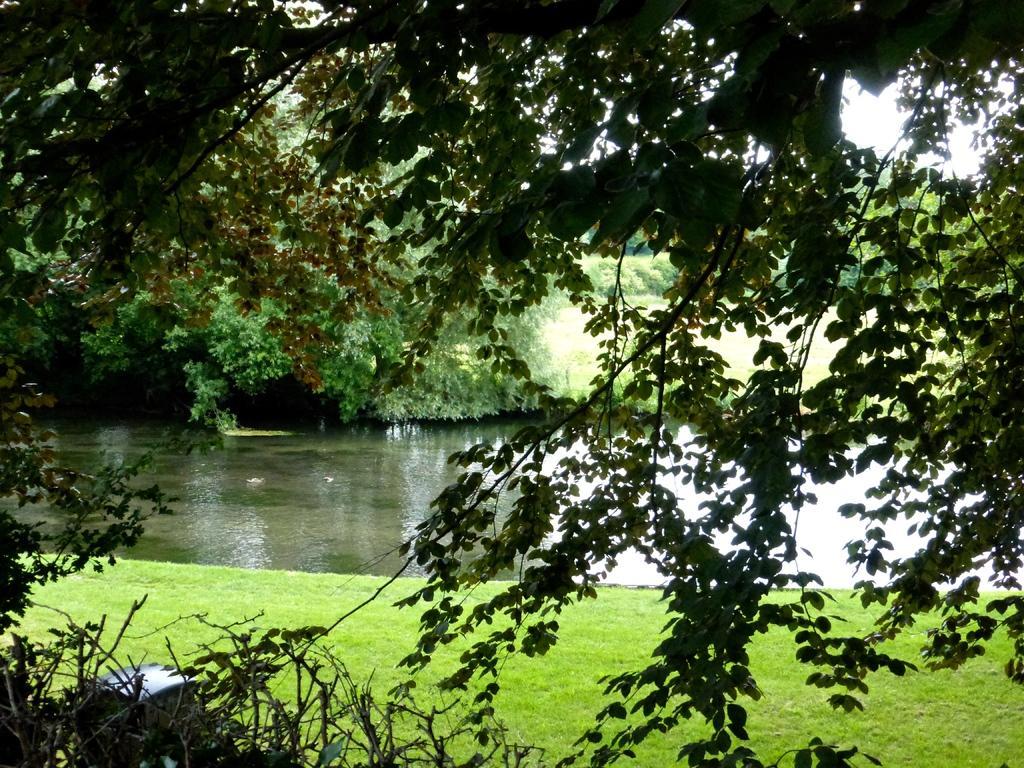In one or two sentences, can you explain what this image depicts? In the picture we can see some trees and grass surface, near to it, we can see water and some plants beside it and some parts of the sky. 